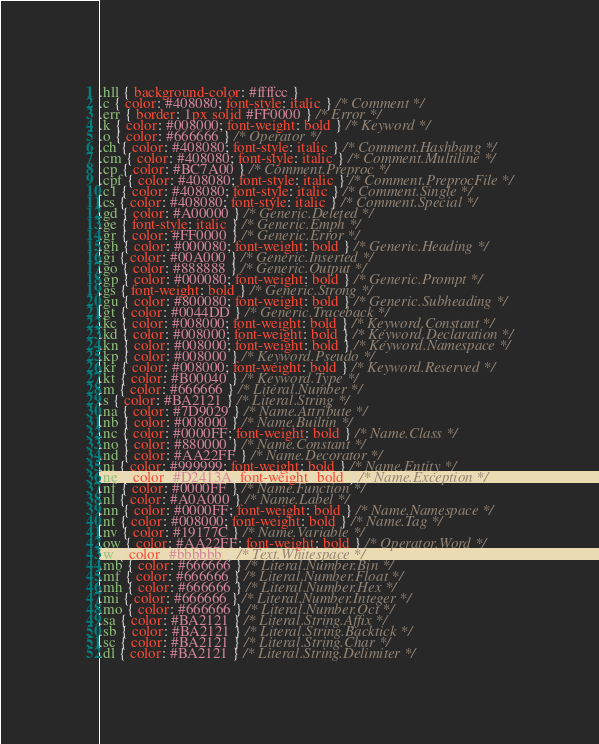Convert code to text. <code><loc_0><loc_0><loc_500><loc_500><_CSS_>.hll { background-color: #ffffcc }
.c { color: #408080; font-style: italic } /* Comment */
.err { border: 1px solid #FF0000 } /* Error */
.k { color: #008000; font-weight: bold } /* Keyword */
.o { color: #666666 } /* Operator */
.ch { color: #408080; font-style: italic } /* Comment.Hashbang */
.cm { color: #408080; font-style: italic } /* Comment.Multiline */
.cp { color: #BC7A00 } /* Comment.Preproc */
.cpf { color: #408080; font-style: italic } /* Comment.PreprocFile */
.c1 { color: #408080; font-style: italic } /* Comment.Single */
.cs { color: #408080; font-style: italic } /* Comment.Special */
.gd { color: #A00000 } /* Generic.Deleted */
.ge { font-style: italic } /* Generic.Emph */
.gr { color: #FF0000 } /* Generic.Error */
.gh { color: #000080; font-weight: bold } /* Generic.Heading */
.gi { color: #00A000 } /* Generic.Inserted */
.go { color: #888888 } /* Generic.Output */
.gp { color: #000080; font-weight: bold } /* Generic.Prompt */
.gs { font-weight: bold } /* Generic.Strong */
.gu { color: #800080; font-weight: bold } /* Generic.Subheading */
.gt { color: #0044DD } /* Generic.Traceback */
.kc { color: #008000; font-weight: bold } /* Keyword.Constant */
.kd { color: #008000; font-weight: bold } /* Keyword.Declaration */
.kn { color: #008000; font-weight: bold } /* Keyword.Namespace */
.kp { color: #008000 } /* Keyword.Pseudo */
.kr { color: #008000; font-weight: bold } /* Keyword.Reserved */
.kt { color: #B00040 } /* Keyword.Type */
.m { color: #666666 } /* Literal.Number */
.s { color: #BA2121 } /* Literal.String */
.na { color: #7D9029 } /* Name.Attribute */
.nb { color: #008000 } /* Name.Builtin */
.nc { color: #0000FF; font-weight: bold } /* Name.Class */
.no { color: #880000 } /* Name.Constant */
.nd { color: #AA22FF } /* Name.Decorator */
.ni { color: #999999; font-weight: bold } /* Name.Entity */
.ne { color: #D2413A; font-weight: bold } /* Name.Exception */
.nf { color: #0000FF } /* Name.Function */
.nl { color: #A0A000 } /* Name.Label */
.nn { color: #0000FF; font-weight: bold } /* Name.Namespace */
.nt { color: #008000; font-weight: bold } /* Name.Tag */
.nv { color: #19177C } /* Name.Variable */
.ow { color: #AA22FF; font-weight: bold } /* Operator.Word */
.w { color: #bbbbbb } /* Text.Whitespace */
.mb { color: #666666 } /* Literal.Number.Bin */
.mf { color: #666666 } /* Literal.Number.Float */
.mh { color: #666666 } /* Literal.Number.Hex */
.mi { color: #666666 } /* Literal.Number.Integer */
.mo { color: #666666 } /* Literal.Number.Oct */
.sa { color: #BA2121 } /* Literal.String.Affix */
.sb { color: #BA2121 } /* Literal.String.Backtick */
.sc { color: #BA2121 } /* Literal.String.Char */
.dl { color: #BA2121 } /* Literal.String.Delimiter */</code> 